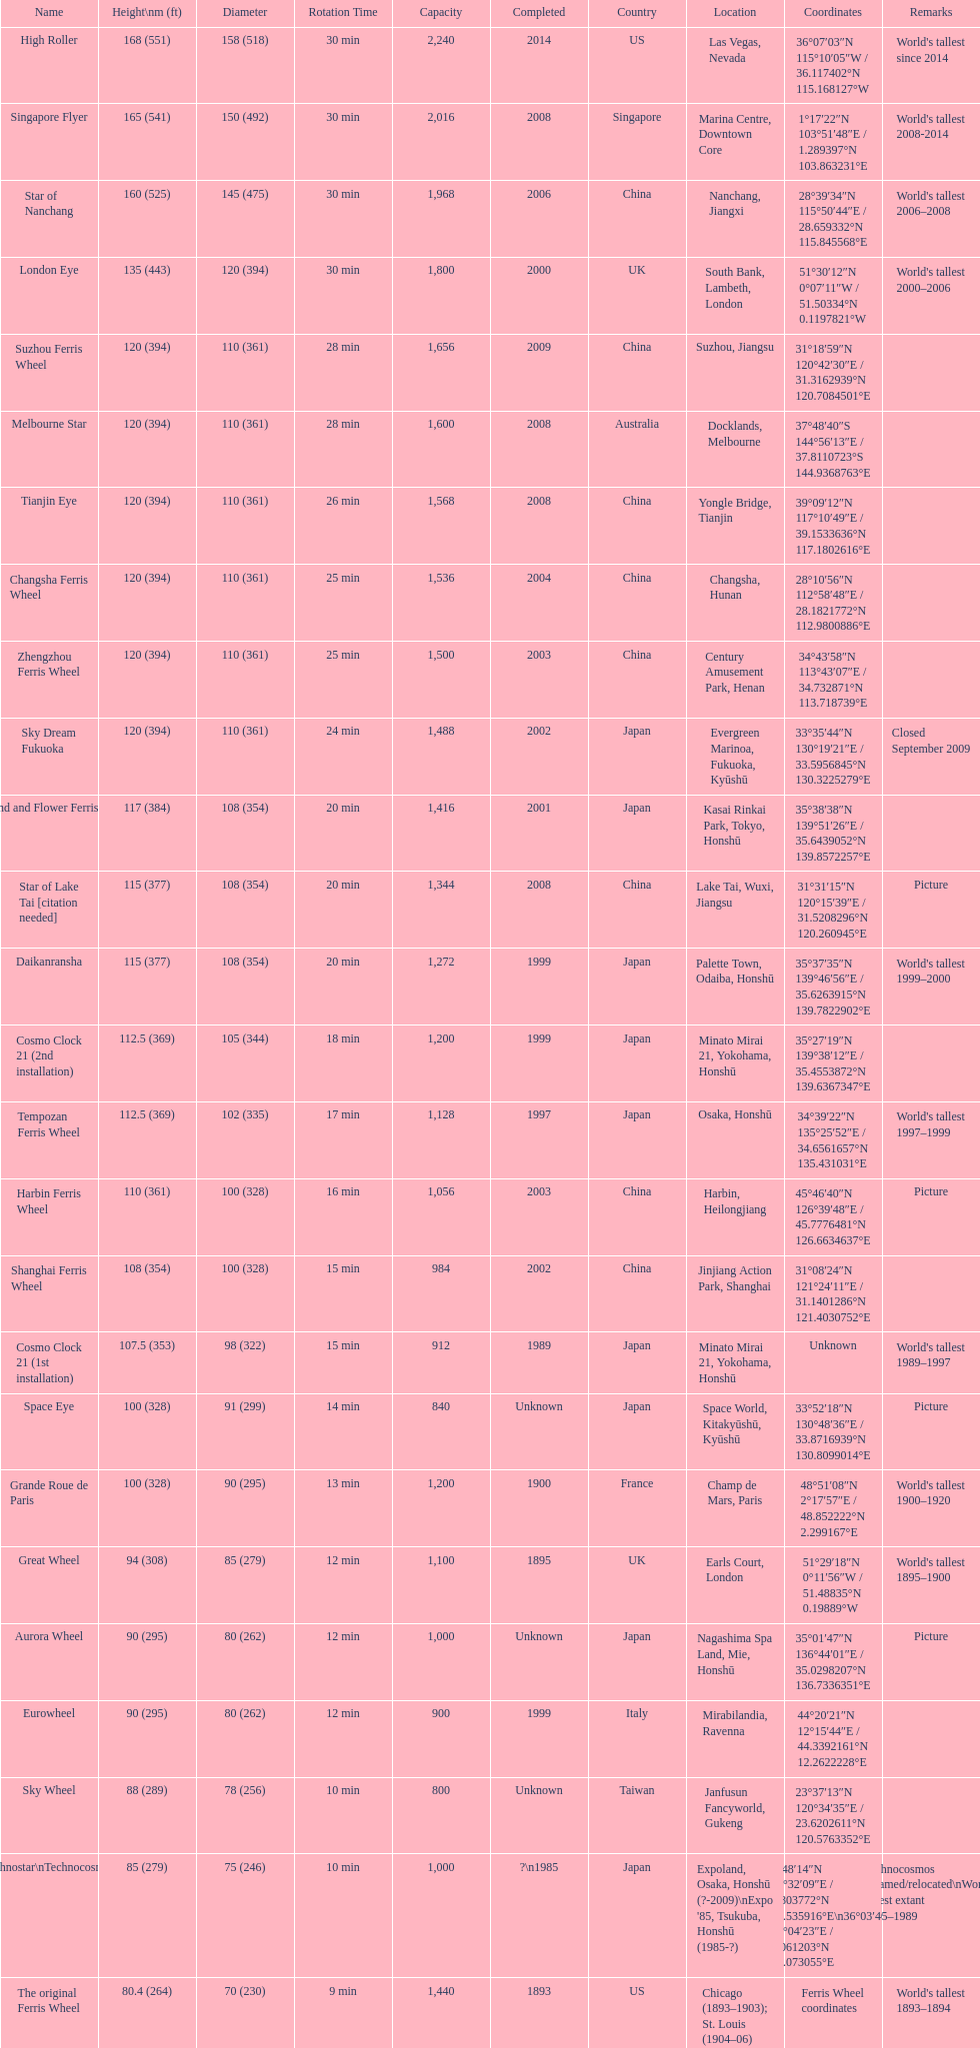Which of these roller coasters has the earliest origin: star of lake tai, star of nanchang, melbourne star? Star of Nanchang. 